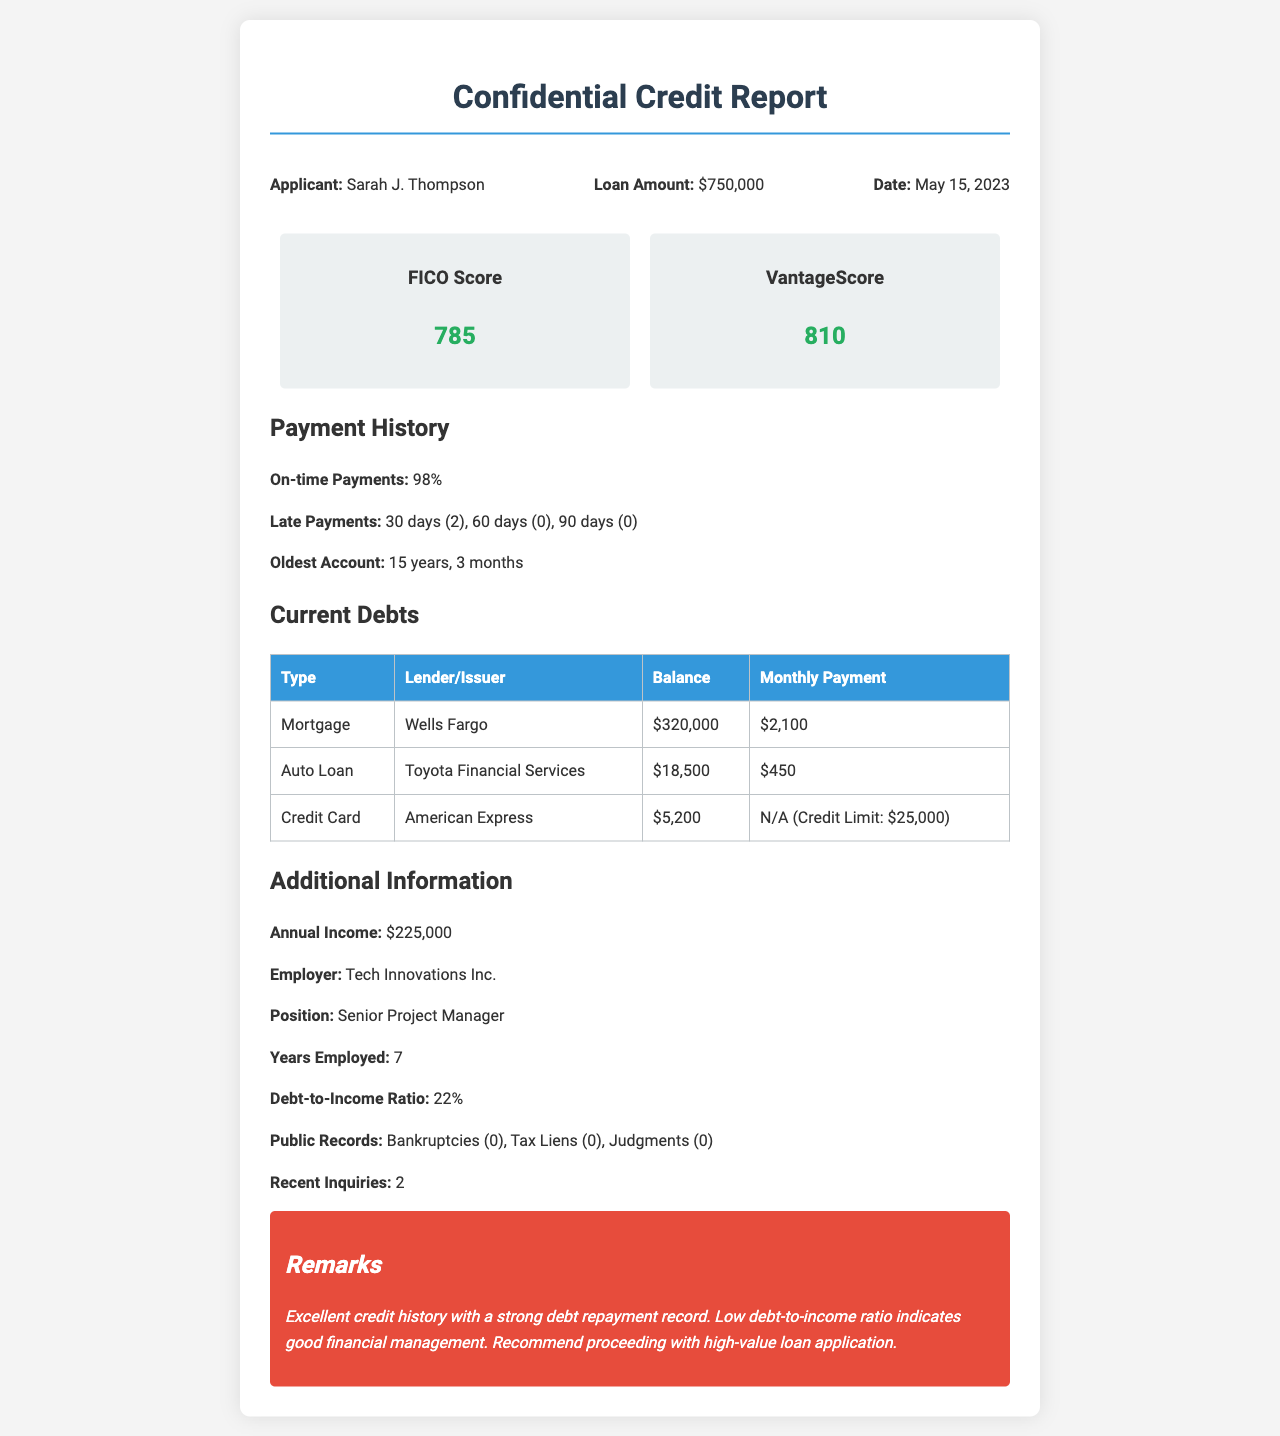What is the applicant's name? The applicant's name is mentioned in the header section of the document.
Answer: Sarah J. Thompson What is the FICO Score of the applicant? The FICO Score is provided in the credit scores section of the document.
Answer: 785 What is the total amount of the loan? The loan amount is stated prominently in the header information.
Answer: $750,000 What is the percentage of on-time payments? The percentage of on-time payments is specified in the payment history section.
Answer: 98% What is the debt-to-income ratio? The debt-to-income ratio can be found in the additional information section of the document.
Answer: 22% Who is the applicant's employer? The employer's name is listed under the additional information section.
Answer: Tech Innovations Inc What is the balance of the credit card debt? The balance of the credit card debt is detailed in the current debts table.
Answer: $5,200 How many late payments were recorded? The number of late payments is detailed in the payment history section.
Answer: 2 What is mentioned about public records? The information regarding public records is summarized in the additional information section.
Answer: Bankruptcies (0), Tax Liens (0), Judgments (0) 